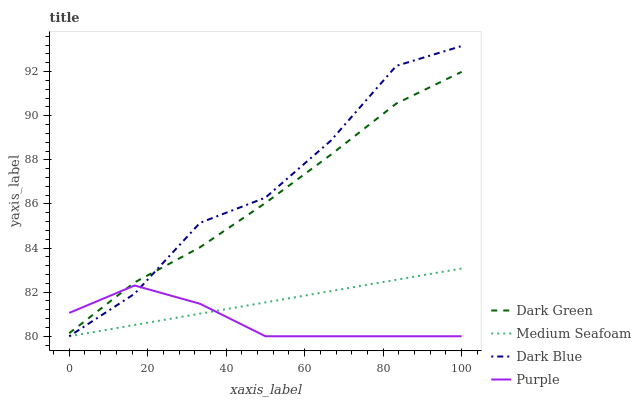Does Purple have the minimum area under the curve?
Answer yes or no. Yes. Does Dark Blue have the maximum area under the curve?
Answer yes or no. Yes. Does Medium Seafoam have the minimum area under the curve?
Answer yes or no. No. Does Medium Seafoam have the maximum area under the curve?
Answer yes or no. No. Is Medium Seafoam the smoothest?
Answer yes or no. Yes. Is Dark Blue the roughest?
Answer yes or no. Yes. Is Dark Blue the smoothest?
Answer yes or no. No. Is Medium Seafoam the roughest?
Answer yes or no. No. Does Purple have the lowest value?
Answer yes or no. Yes. Does Dark Green have the lowest value?
Answer yes or no. No. Does Dark Blue have the highest value?
Answer yes or no. Yes. Does Medium Seafoam have the highest value?
Answer yes or no. No. Is Medium Seafoam less than Dark Green?
Answer yes or no. Yes. Is Dark Green greater than Medium Seafoam?
Answer yes or no. Yes. Does Dark Green intersect Dark Blue?
Answer yes or no. Yes. Is Dark Green less than Dark Blue?
Answer yes or no. No. Is Dark Green greater than Dark Blue?
Answer yes or no. No. Does Medium Seafoam intersect Dark Green?
Answer yes or no. No. 